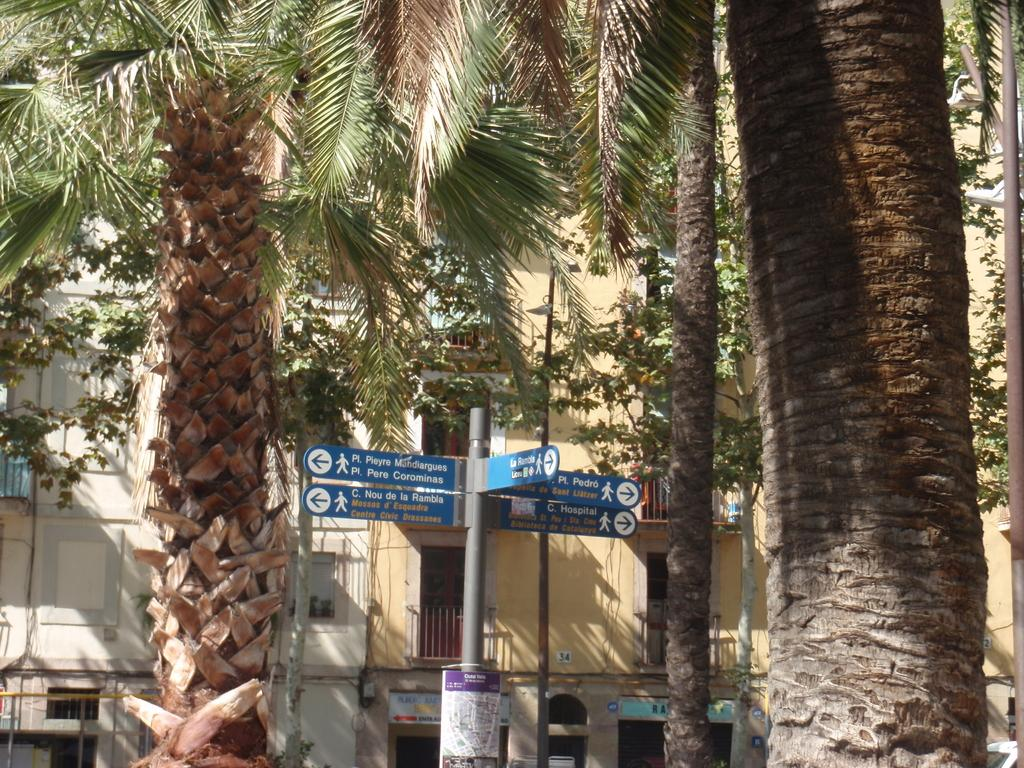What can be seen on the poles in the image? There are signboards on poles in the image. What is visible in the background of the image? There are trees and buildings in the background of the image. How many pairs of shoes are hanging from the signboards in the image? There are no shoes hanging from the signboards in the image. 